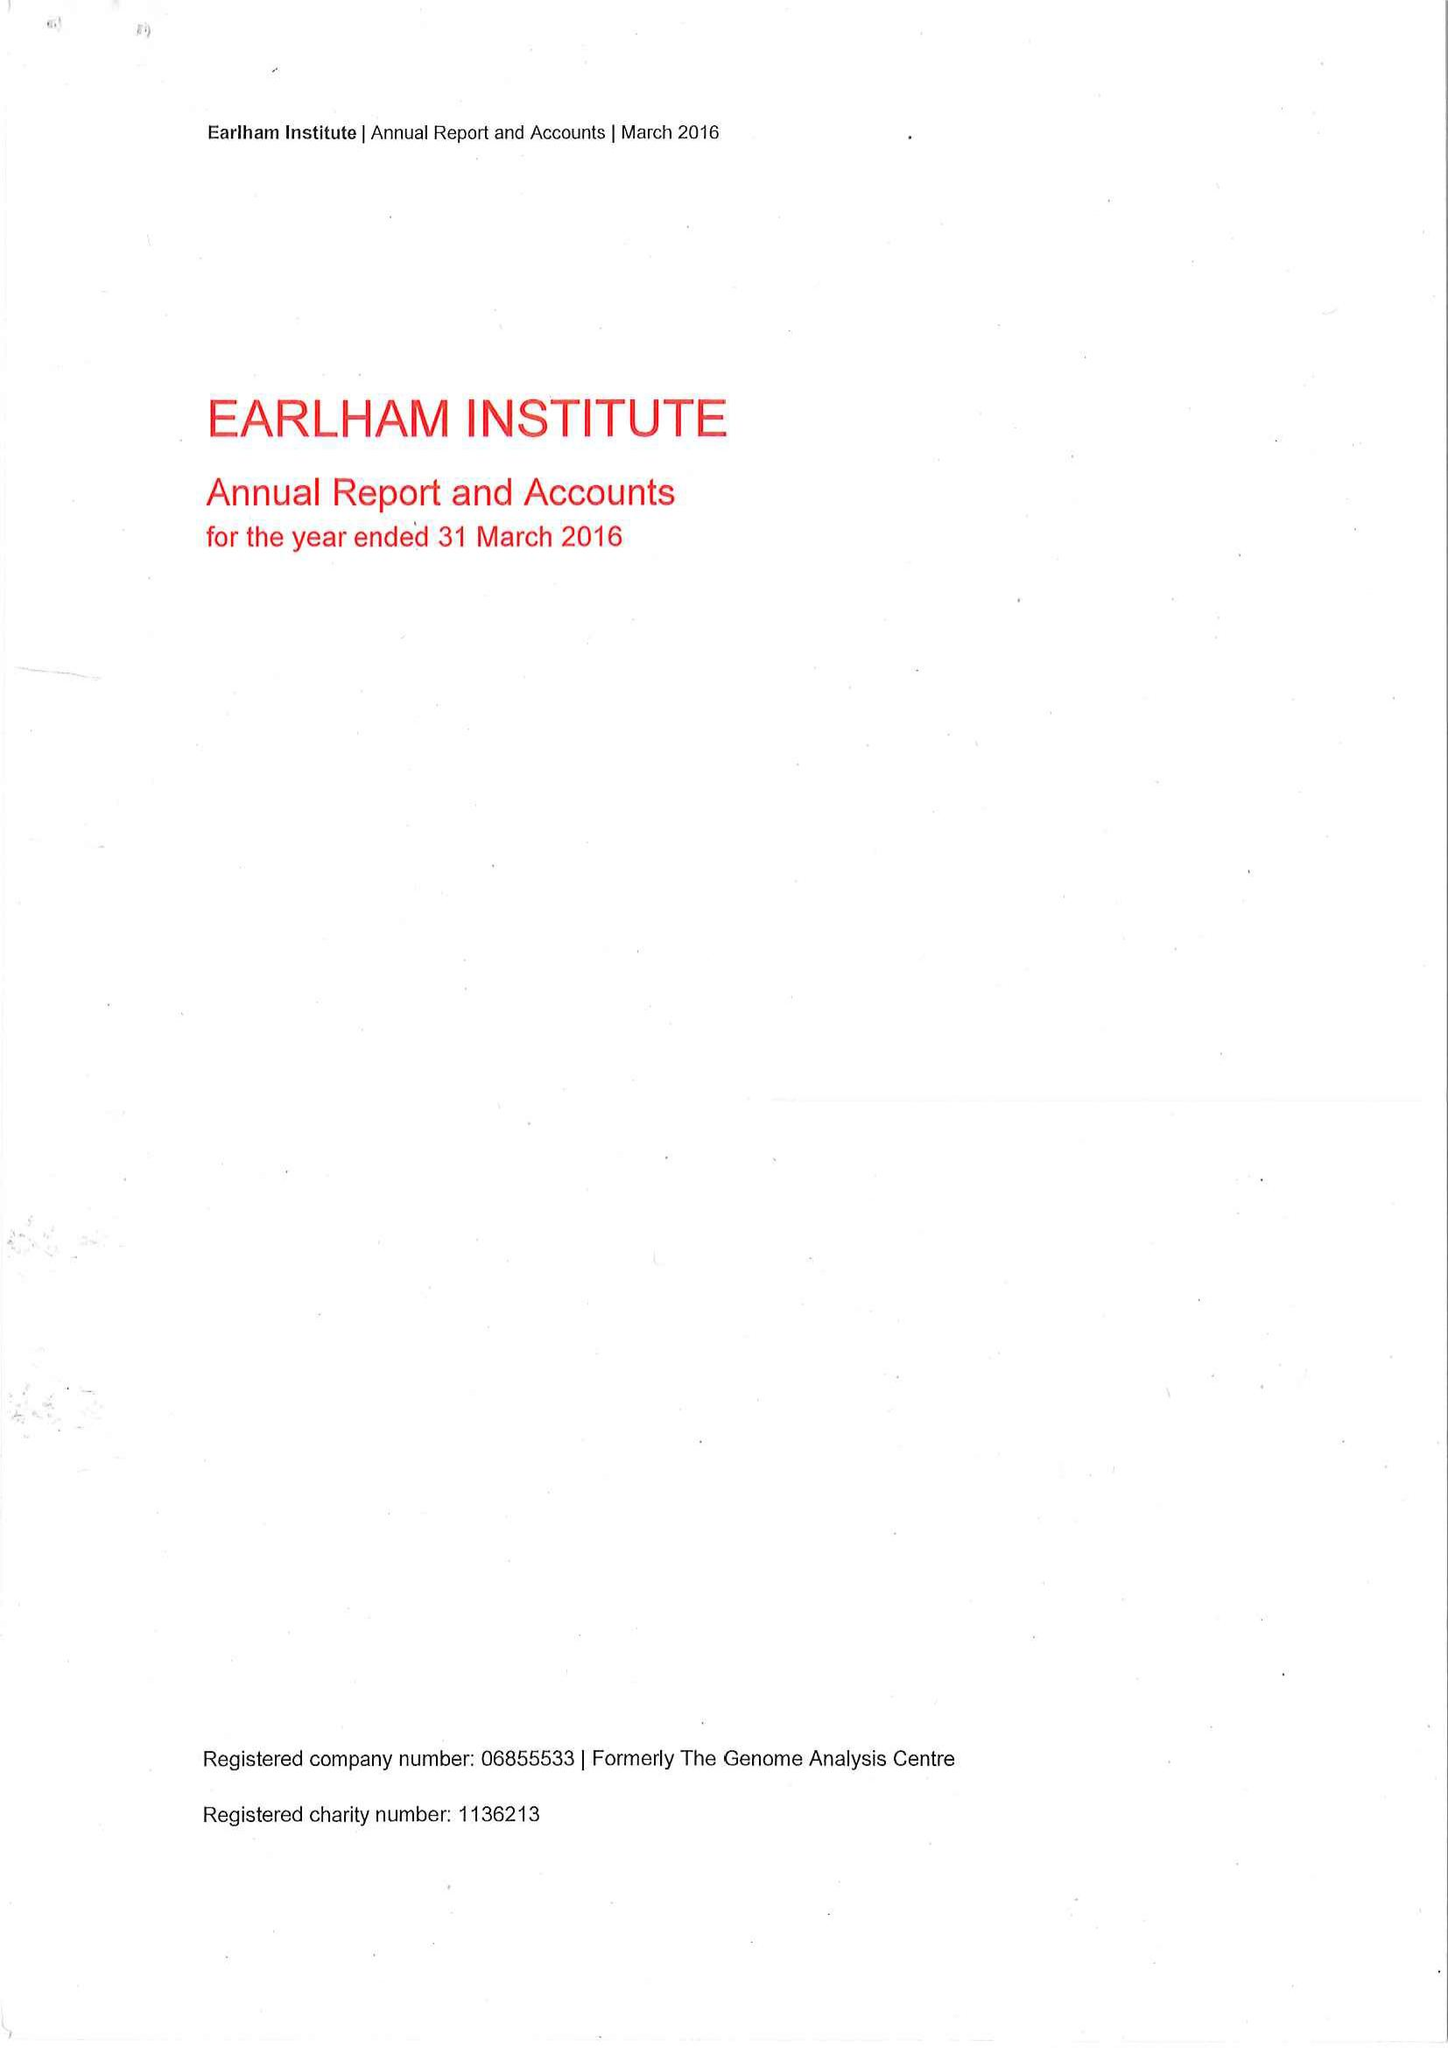What is the value for the charity_number?
Answer the question using a single word or phrase. 1136213 